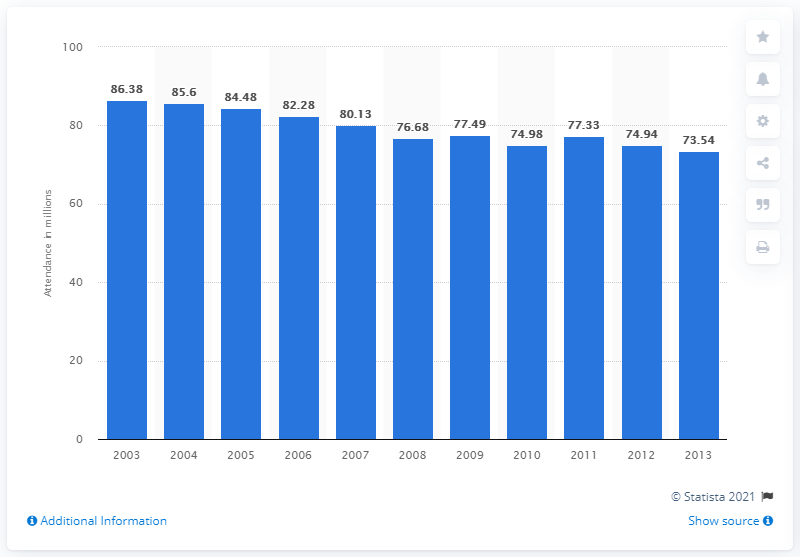Identify some key points in this picture. In 2013, approximately 73.54 people attended a performing arts event at least once. 